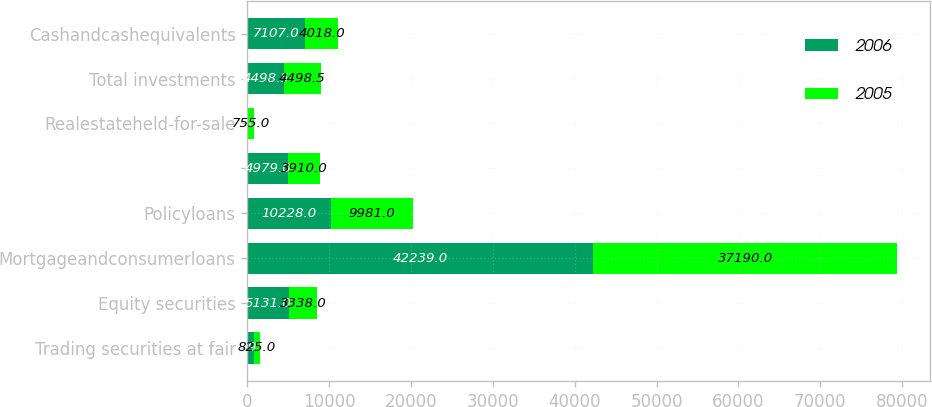<chart> <loc_0><loc_0><loc_500><loc_500><stacked_bar_chart><ecel><fcel>Trading securities at fair<fcel>Equity securities<fcel>Mortgageandconsumerloans<fcel>Policyloans<fcel>Unnamed: 5<fcel>Realestateheld-for-sale<fcel>Total investments<fcel>Cashandcashequivalents<nl><fcel>2006<fcel>759<fcel>5131<fcel>42239<fcel>10228<fcel>4979<fcel>7<fcel>4498.5<fcel>7107<nl><fcel>2005<fcel>825<fcel>3338<fcel>37190<fcel>9981<fcel>3910<fcel>755<fcel>4498.5<fcel>4018<nl></chart> 